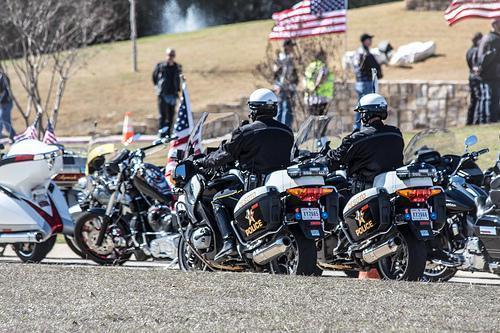How many police officers are on the bikes?
Give a very brief answer. 2. 